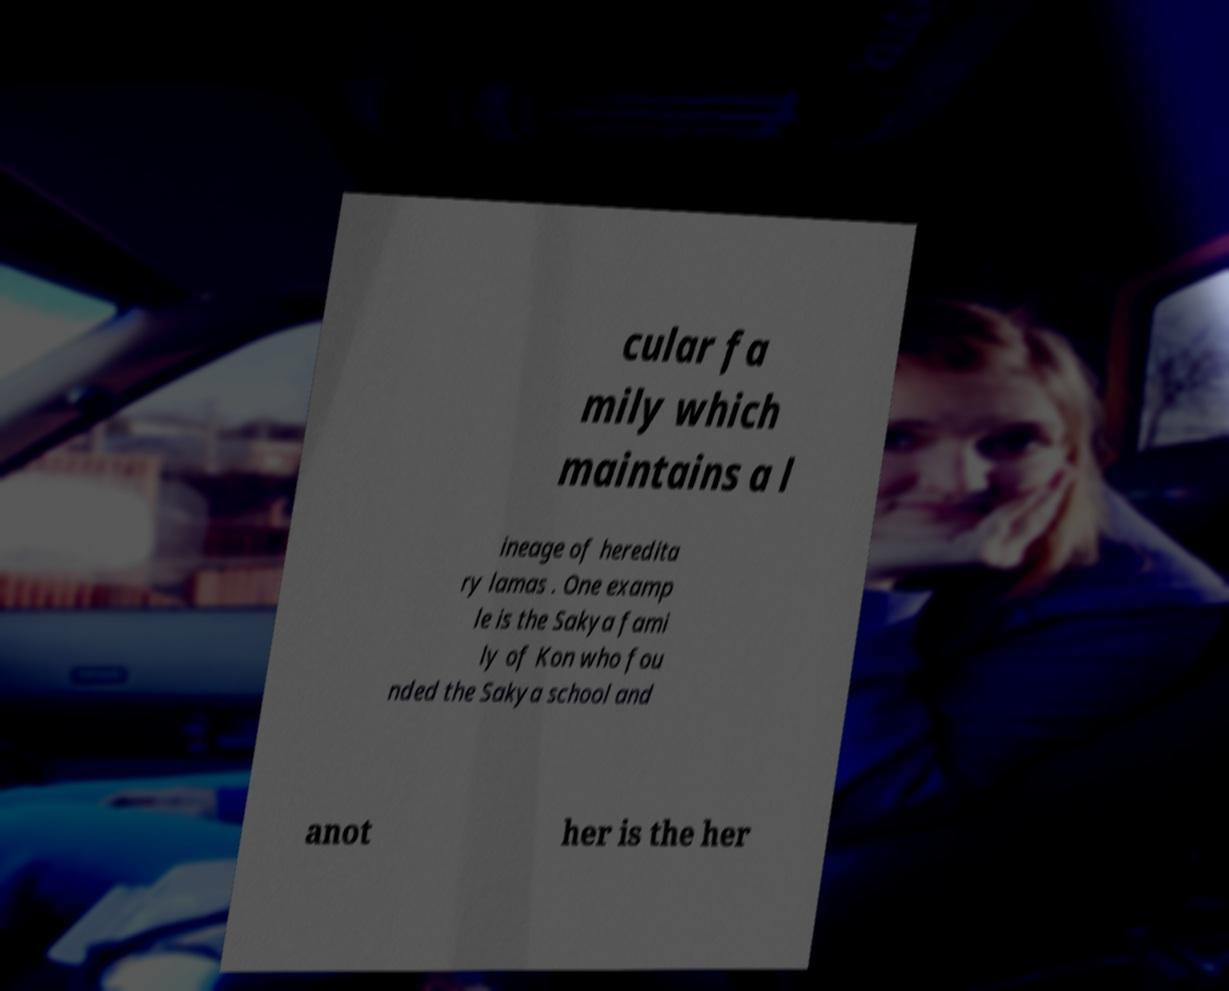Could you assist in decoding the text presented in this image and type it out clearly? cular fa mily which maintains a l ineage of heredita ry lamas . One examp le is the Sakya fami ly of Kon who fou nded the Sakya school and anot her is the her 